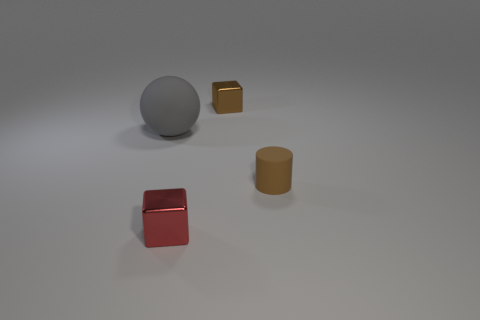Add 2 tiny red shiny blocks. How many objects exist? 6 Subtract all cylinders. How many objects are left? 3 Subtract all big matte balls. Subtract all tiny brown matte cylinders. How many objects are left? 2 Add 3 tiny metallic cubes. How many tiny metallic cubes are left? 5 Add 3 large blue shiny cubes. How many large blue shiny cubes exist? 3 Subtract 1 brown blocks. How many objects are left? 3 